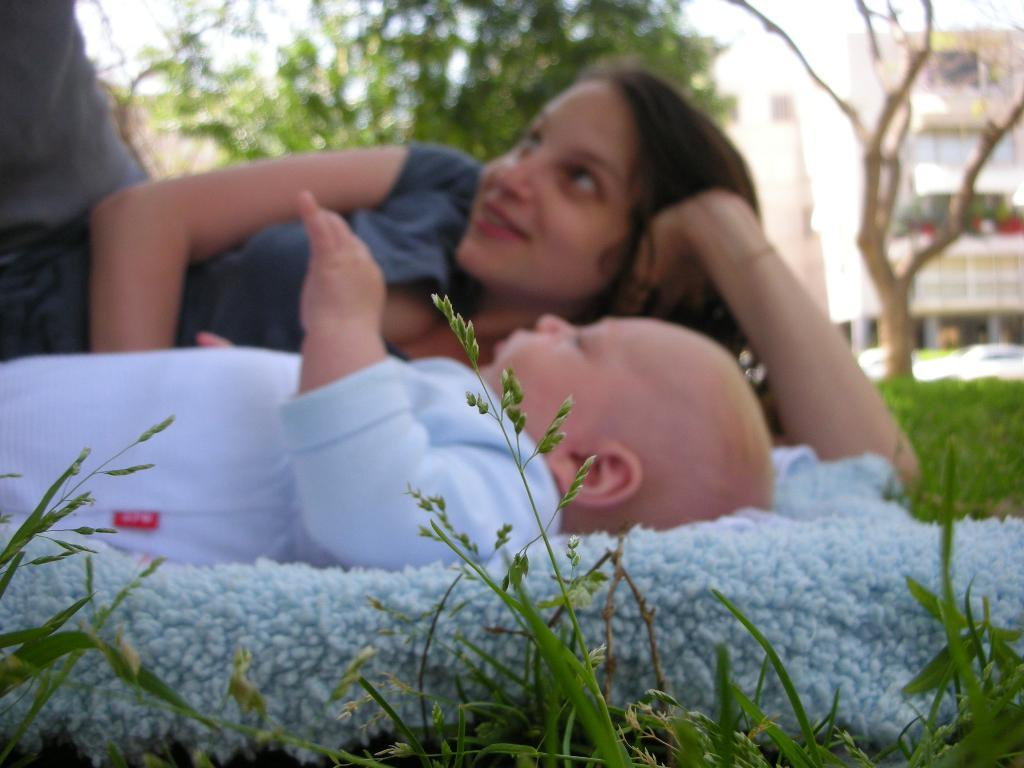What is covering the ground in the image? There is a blanket in the image. What is on top of the blanket? A baby and a woman are lying on the blanket. What can be seen in the background of the image? There are trees and buildings in the background of the image. How is the background of the image depicted? The background is blurred. What type of cloth is being distributed during the battle in the image? There is no battle or distribution of cloth present in the image. 